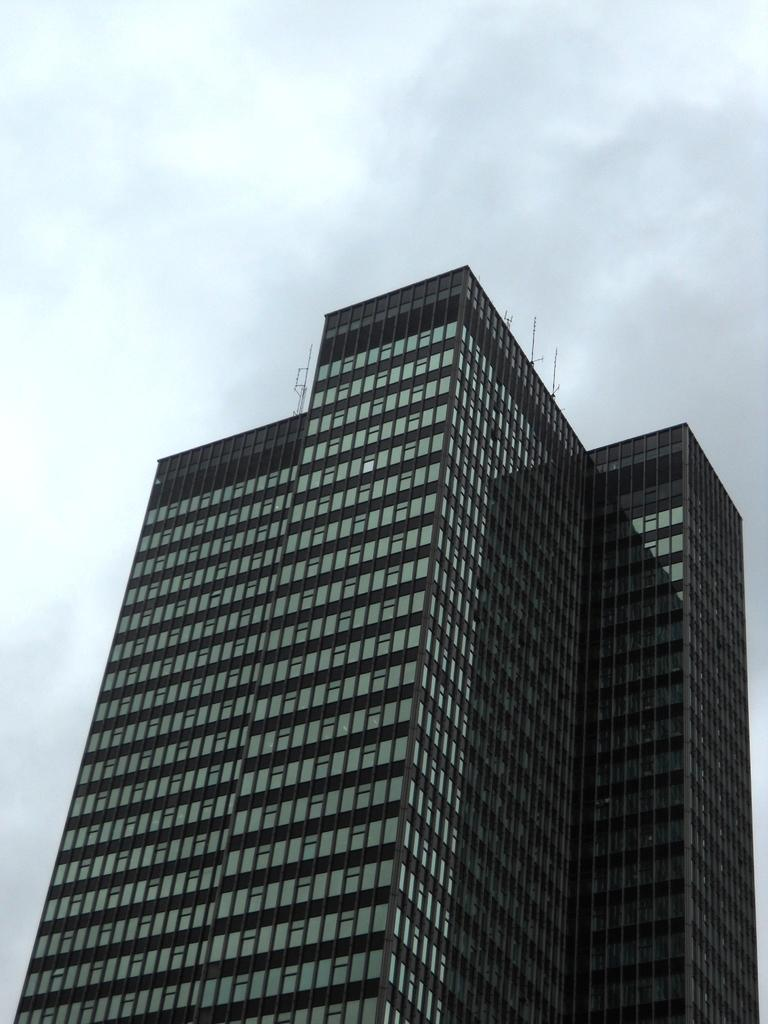What type of structure is present in the image? There is a building in the image. What part of the natural environment is visible in the image? The sky is visible in the image. Can you determine the time of day the image was taken? Yes, the image was taken during the day. Can you see any sheep grazing near the river in the image? There are no sheep or river present in the image; it features a building and the sky. 